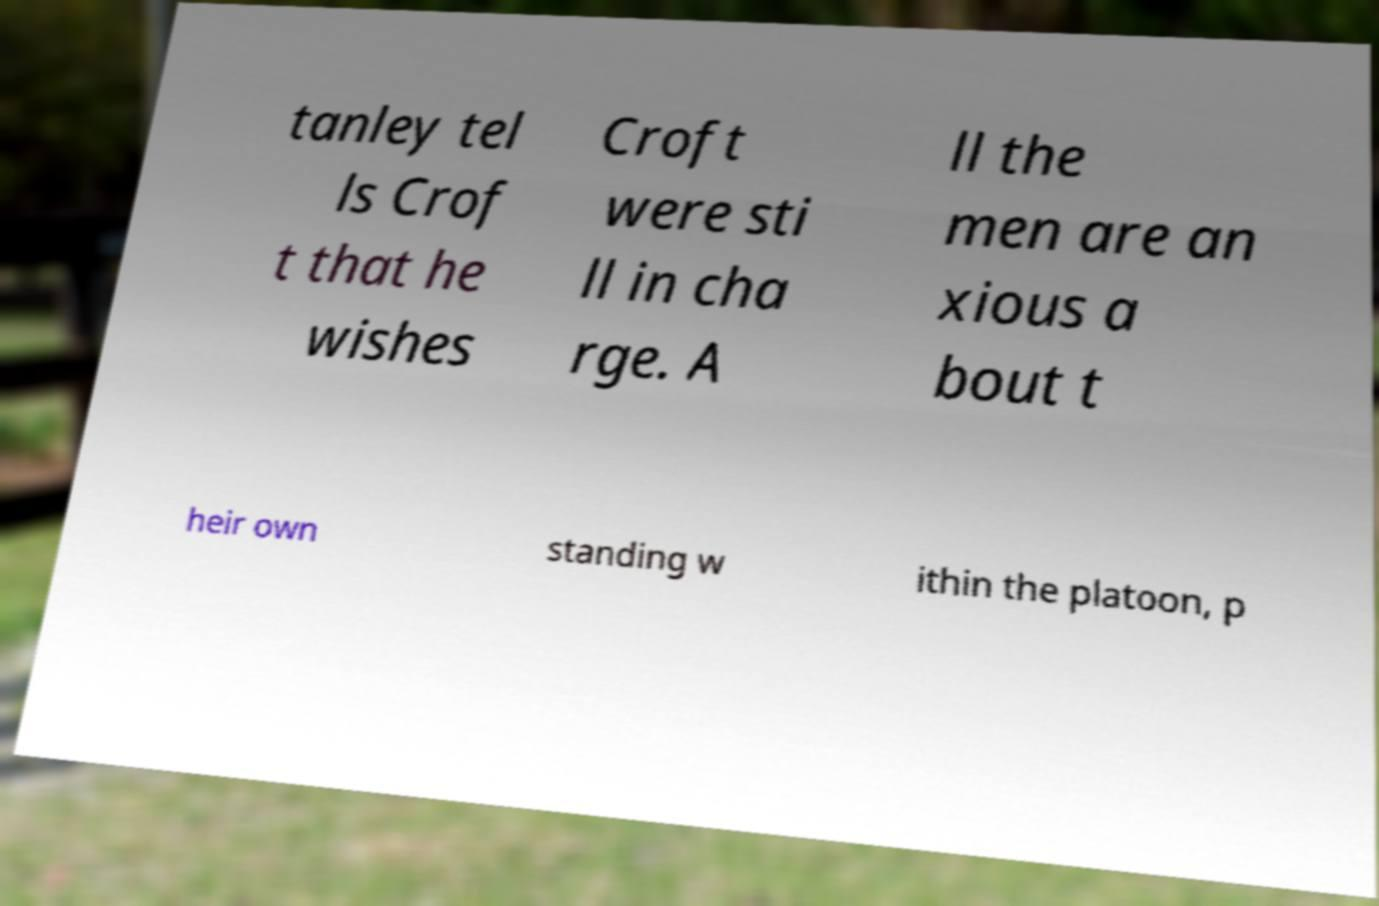Could you assist in decoding the text presented in this image and type it out clearly? tanley tel ls Crof t that he wishes Croft were sti ll in cha rge. A ll the men are an xious a bout t heir own standing w ithin the platoon, p 